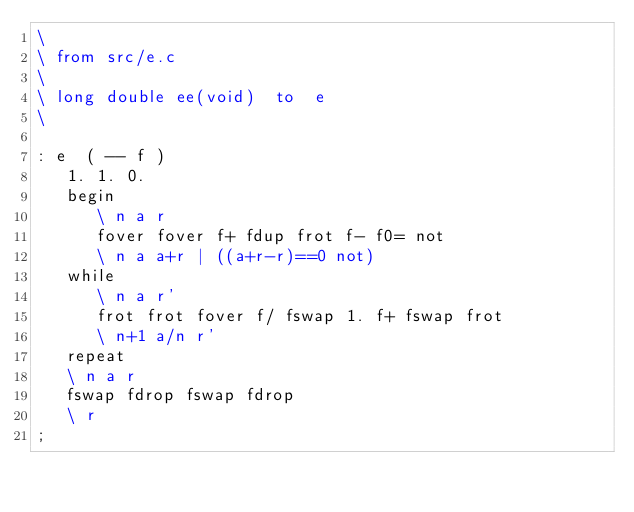<code> <loc_0><loc_0><loc_500><loc_500><_Forth_>\
\	from src/e.c
\
\	long double ee(void)	to	e
\

: e  ( -- f )
   1. 1. 0.
   begin
      \ n a r
      fover fover f+ fdup frot f- f0= not
      \ n a a+r | ((a+r-r)==0 not)
   while
      \ n a r'
      frot frot fover f/ fswap 1. f+ fswap frot
      \ n+1 a/n r'
   repeat
   \ n a r
   fswap fdrop fswap fdrop
   \ r
;
</code> 